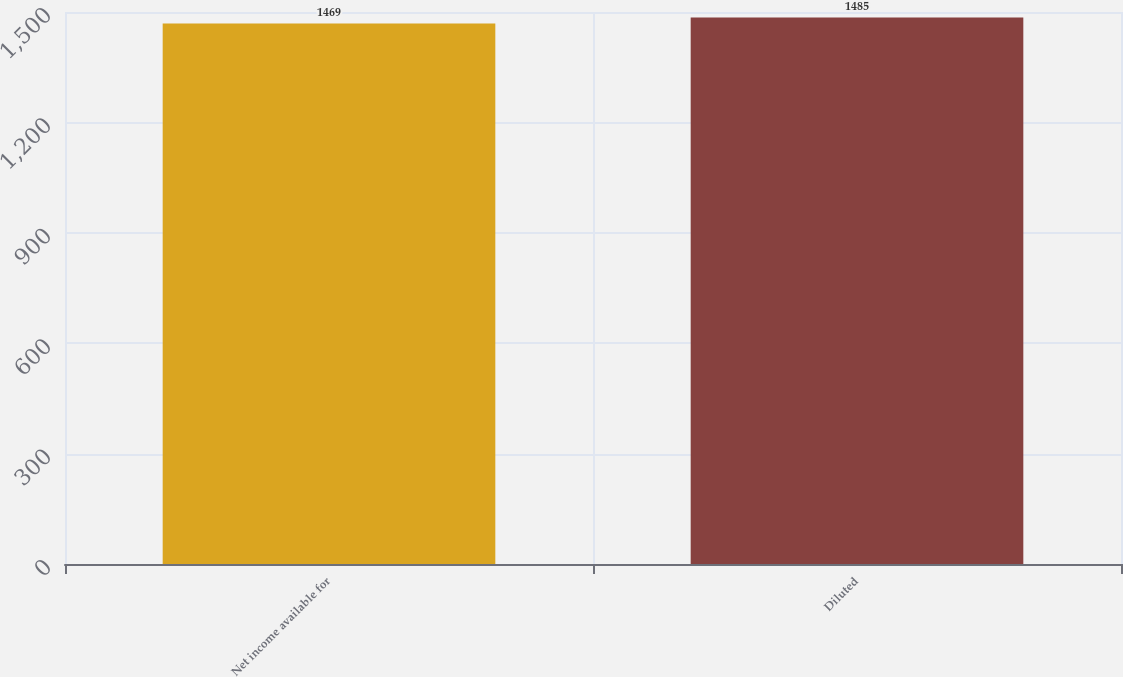<chart> <loc_0><loc_0><loc_500><loc_500><bar_chart><fcel>Net income available for<fcel>Diluted<nl><fcel>1469<fcel>1485<nl></chart> 